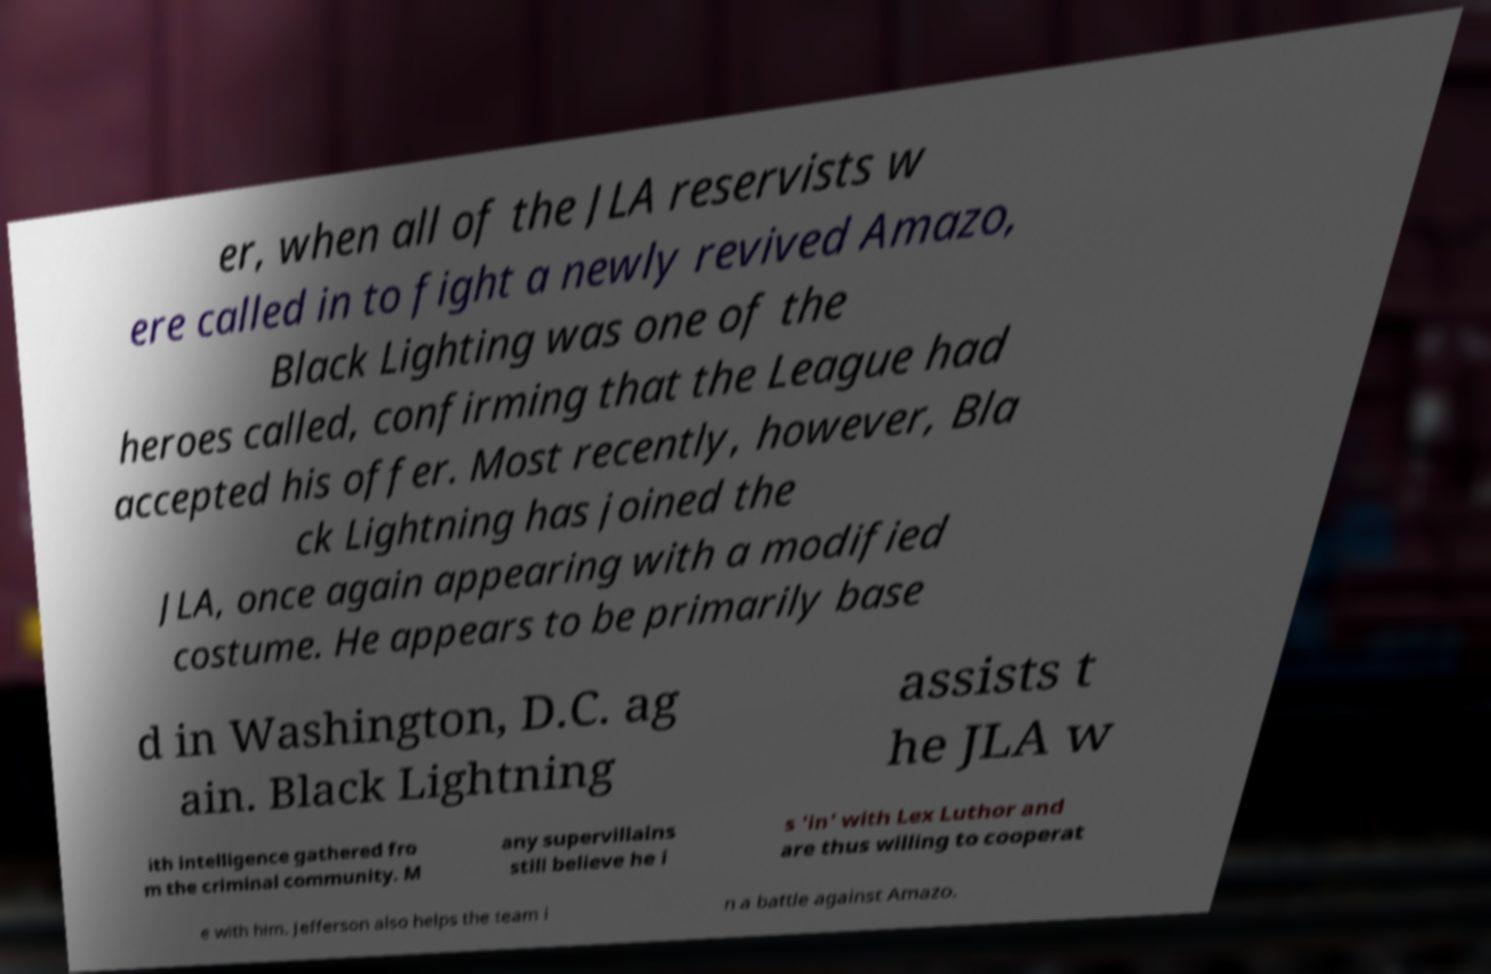What messages or text are displayed in this image? I need them in a readable, typed format. er, when all of the JLA reservists w ere called in to fight a newly revived Amazo, Black Lighting was one of the heroes called, confirming that the League had accepted his offer. Most recently, however, Bla ck Lightning has joined the JLA, once again appearing with a modified costume. He appears to be primarily base d in Washington, D.C. ag ain. Black Lightning assists t he JLA w ith intelligence gathered fro m the criminal community. M any supervillains still believe he i s 'in' with Lex Luthor and are thus willing to cooperat e with him. Jefferson also helps the team i n a battle against Amazo. 